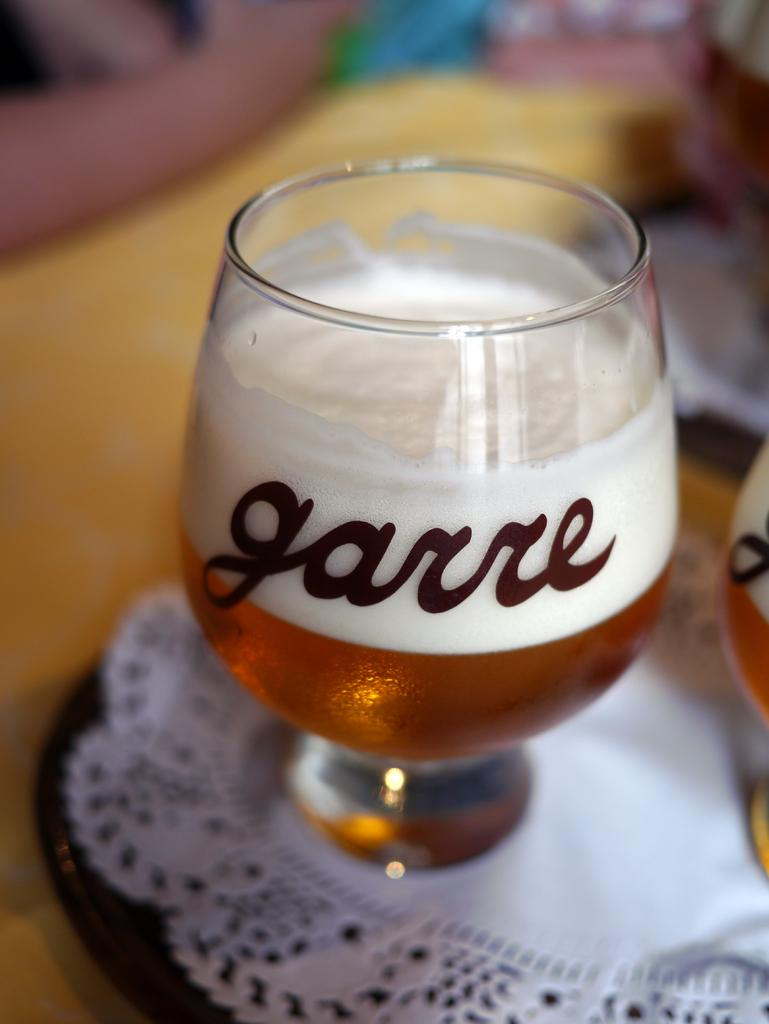What is in the glasses that are visible in the image? There are glasses with wine in the image. How are the glasses arranged in the image? The glasses are placed on a plate. What other objects can be seen in the image besides the glasses with wine? There are other objects present in the image, but their specific details are not mentioned in the provided facts. What type of rhythm can be heard in the image? There is no sound or music present in the image, so it is not possible to determine any rhythm. 